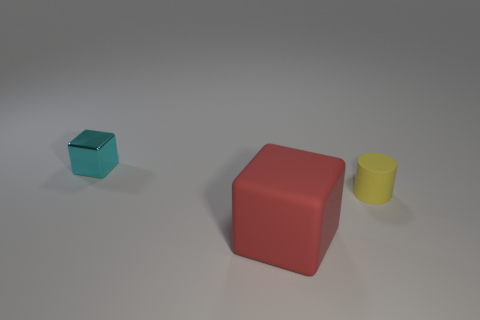Is there any other thing that is made of the same material as the small cyan object?
Keep it short and to the point. No. There is a yellow object; is it the same size as the rubber object that is left of the small yellow rubber cylinder?
Your answer should be very brief. No. What is the color of the other object that is the same shape as the cyan metal object?
Give a very brief answer. Red. Do the matte thing that is behind the red thing and the block that is right of the cyan metallic object have the same size?
Provide a short and direct response. No. Does the tiny cyan metallic thing have the same shape as the small matte object?
Keep it short and to the point. No. How many things are either big red matte things that are in front of the yellow cylinder or red metallic things?
Your answer should be compact. 1. Are there any blue shiny objects that have the same shape as the yellow rubber object?
Provide a short and direct response. No. Are there an equal number of big red matte blocks that are on the left side of the rubber cube and objects?
Your answer should be compact. No. What number of other metallic cubes have the same size as the cyan cube?
Your answer should be very brief. 0. How many tiny things are behind the yellow matte object?
Provide a short and direct response. 1. 